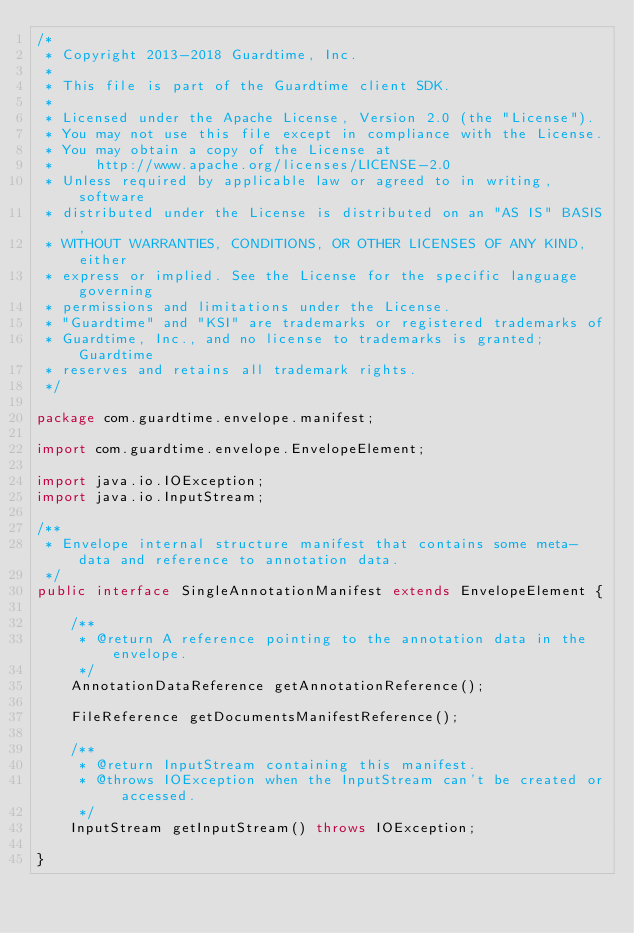Convert code to text. <code><loc_0><loc_0><loc_500><loc_500><_Java_>/*
 * Copyright 2013-2018 Guardtime, Inc.
 *
 * This file is part of the Guardtime client SDK.
 *
 * Licensed under the Apache License, Version 2.0 (the "License").
 * You may not use this file except in compliance with the License.
 * You may obtain a copy of the License at
 *     http://www.apache.org/licenses/LICENSE-2.0
 * Unless required by applicable law or agreed to in writing, software
 * distributed under the License is distributed on an "AS IS" BASIS,
 * WITHOUT WARRANTIES, CONDITIONS, OR OTHER LICENSES OF ANY KIND, either
 * express or implied. See the License for the specific language governing
 * permissions and limitations under the License.
 * "Guardtime" and "KSI" are trademarks or registered trademarks of
 * Guardtime, Inc., and no license to trademarks is granted; Guardtime
 * reserves and retains all trademark rights.
 */

package com.guardtime.envelope.manifest;

import com.guardtime.envelope.EnvelopeElement;

import java.io.IOException;
import java.io.InputStream;

/**
 * Envelope internal structure manifest that contains some meta-data and reference to annotation data.
 */
public interface SingleAnnotationManifest extends EnvelopeElement {

    /**
     * @return A reference pointing to the annotation data in the envelope.
     */
    AnnotationDataReference getAnnotationReference();

    FileReference getDocumentsManifestReference();

    /**
     * @return InputStream containing this manifest.
     * @throws IOException when the InputStream can't be created or accessed.
     */
    InputStream getInputStream() throws IOException;

}
</code> 